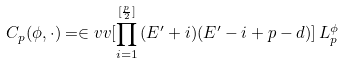Convert formula to latex. <formula><loc_0><loc_0><loc_500><loc_500>C _ { p } ( \phi , \cdot ) = \in v v [ \prod _ { i = 1 } ^ { [ \frac { p } { 2 } ] } \, ( E ^ { \prime } + i ) ( E ^ { \prime } - i + p - d ) ] \, L ^ { \phi } _ { p }</formula> 